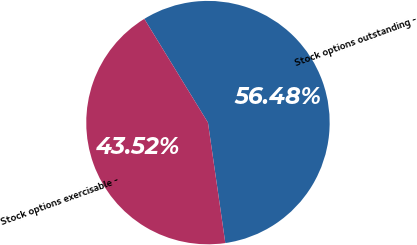Convert chart. <chart><loc_0><loc_0><loc_500><loc_500><pie_chart><fcel>Stock options outstanding -<fcel>Stock options exercisable -<nl><fcel>56.48%<fcel>43.52%<nl></chart> 